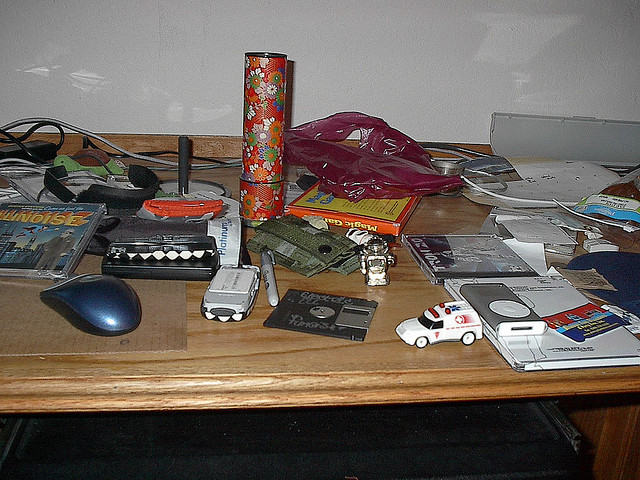<image>What video game is sitting on the desk? I don't know what video game is sitting on the desk. It can be 'war', 'illinois', 'pac man', 'halo', 'magic card' or 'cd'. What video game is sitting on the desk? I don't know what video game is sitting on the desk. 